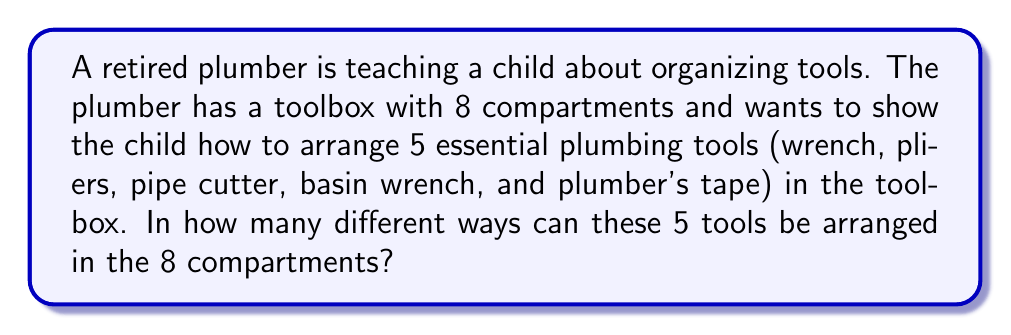Solve this math problem. Let's approach this step-by-step:

1) This is a permutation problem because the order of the tools matters in the arrangement.

2) We have 8 compartments (spaces) and 5 tools to arrange.

3) For the first tool, we have 8 choices of compartments.

4) For the second tool, we have 7 remaining choices.

5) For the third tool, we have 6 remaining choices.

6) For the fourth tool, we have 5 remaining choices.

7) For the fifth and final tool, we have 4 remaining choices.

8) Using the multiplication principle, the total number of ways to arrange the tools is:

   $$8 \times 7 \times 6 \times 5 \times 4$$

9) This can be written as a permutation:

   $$P(8,5) = \frac{8!}{(8-5)!} = \frac{8!}{3!}$$

10) Calculating this:
    
    $$\frac{8 \times 7 \times 6 \times 5 \times 4 \times 3!}{3!} = 8 \times 7 \times 6 \times 5 \times 4 = 6720$$

Therefore, there are 6720 different ways to arrange the 5 tools in the 8 compartments.
Answer: 6720 